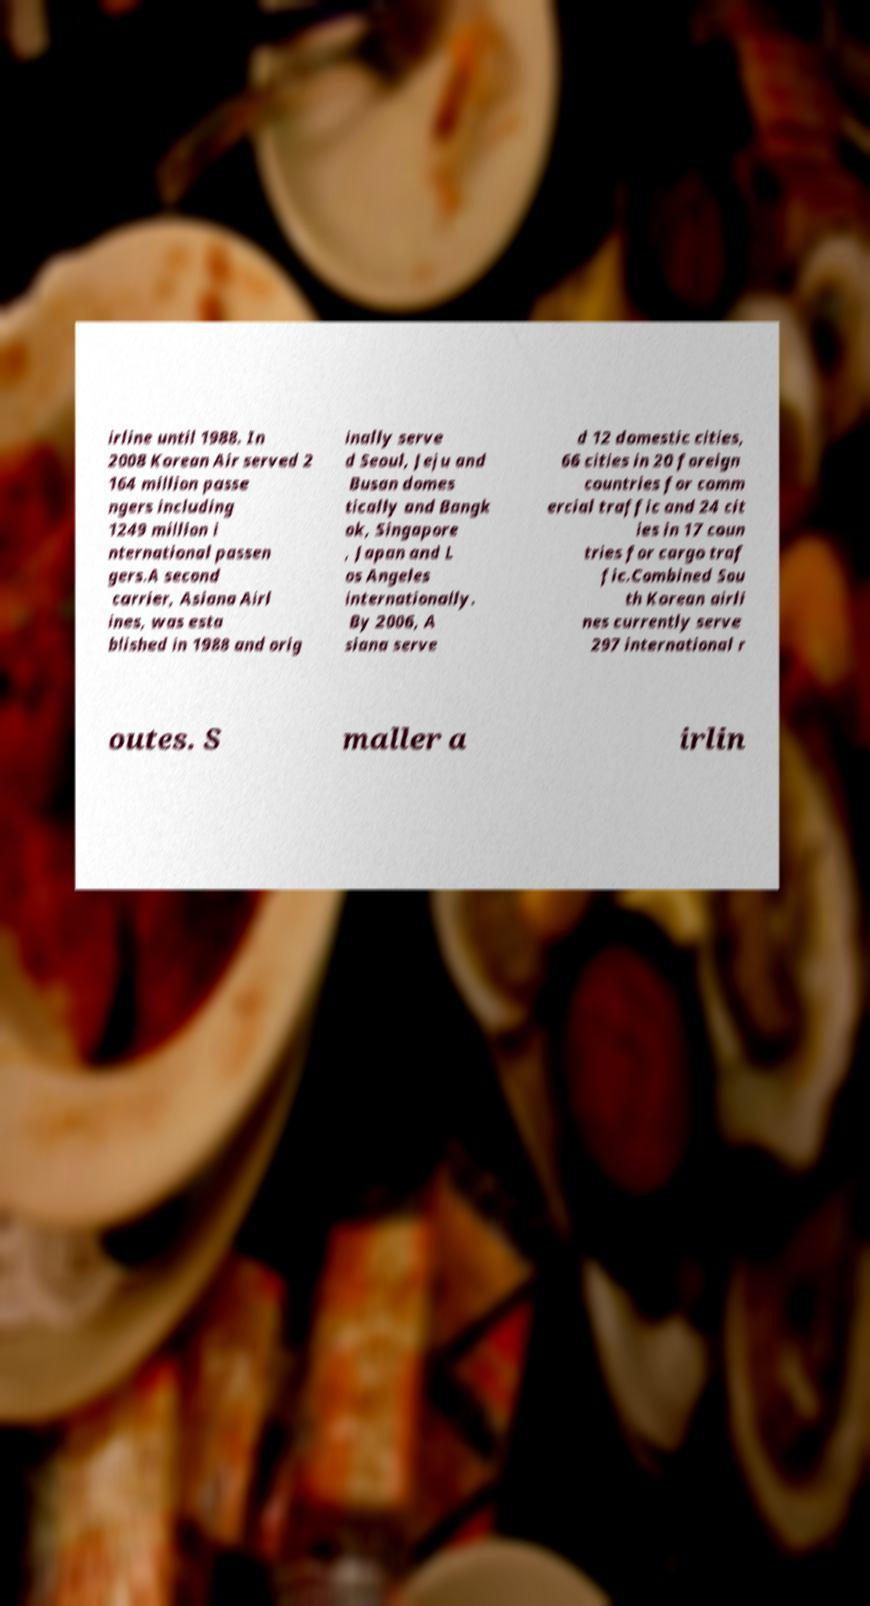For documentation purposes, I need the text within this image transcribed. Could you provide that? irline until 1988. In 2008 Korean Air served 2 164 million passe ngers including 1249 million i nternational passen gers.A second carrier, Asiana Airl ines, was esta blished in 1988 and orig inally serve d Seoul, Jeju and Busan domes tically and Bangk ok, Singapore , Japan and L os Angeles internationally. By 2006, A siana serve d 12 domestic cities, 66 cities in 20 foreign countries for comm ercial traffic and 24 cit ies in 17 coun tries for cargo traf fic.Combined Sou th Korean airli nes currently serve 297 international r outes. S maller a irlin 